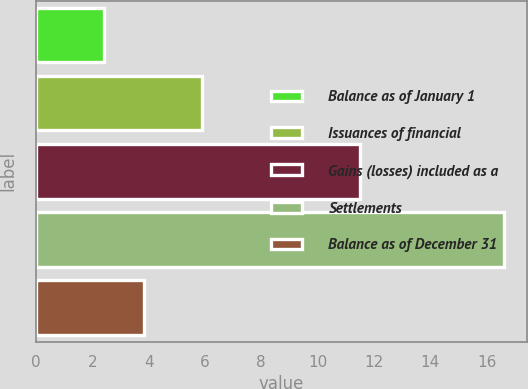<chart> <loc_0><loc_0><loc_500><loc_500><bar_chart><fcel>Balance as of January 1<fcel>Issuances of financial<fcel>Gains (losses) included as a<fcel>Settlements<fcel>Balance as of December 31<nl><fcel>2.4<fcel>5.9<fcel>11.5<fcel>16.6<fcel>3.82<nl></chart> 